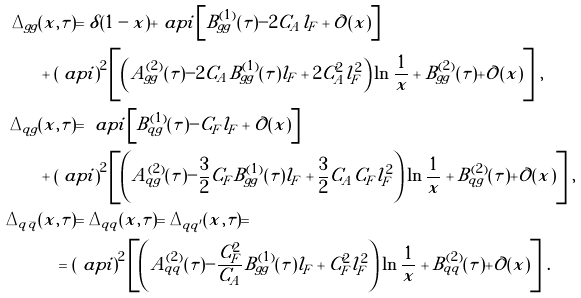<formula> <loc_0><loc_0><loc_500><loc_500>\Delta _ { g g } & ( x , \tau ) = \delta ( 1 - x ) + \ a p i \left [ B ^ { ( 1 ) } _ { g g } ( \tau ) - 2 C _ { A } l _ { F } + \mathcal { O } ( x ) \right ] \\ & + \left ( \ a p i \right ) ^ { 2 } \left [ \left ( A ^ { ( 2 ) } _ { g g } ( \tau ) - 2 C _ { A } B ^ { ( 1 ) } _ { g g } ( \tau ) l _ { F } + 2 C _ { A } ^ { 2 } l _ { F } ^ { 2 } \right ) \ln \frac { 1 } { x } + B ^ { ( 2 ) } _ { g g } ( \tau ) + \mathcal { O } ( x ) \right ] \, , \\ \Delta _ { q g } & ( x , \tau ) = \ a p i \left [ B ^ { ( 1 ) } _ { q g } ( \tau ) - C _ { F } l _ { F } + \mathcal { O } ( x ) \right ] \\ & + \left ( \ a p i \right ) ^ { 2 } \left [ \left ( A ^ { ( 2 ) } _ { q g } ( \tau ) - \frac { 3 } { 2 } C _ { F } B ^ { ( 1 ) } _ { g g } ( \tau ) l _ { F } + \frac { 3 } { 2 } C _ { A } C _ { F } l _ { F } ^ { 2 } \right ) \ln \frac { 1 } { x } + B ^ { ( 2 ) } _ { q g } ( \tau ) + \mathcal { O } ( x ) \right ] \, , \\ \Delta _ { q \bar { q } } & ( x , \tau ) = \Delta _ { q q } ( x , \tau ) = \Delta _ { q q ^ { \prime } } ( x , \tau ) = \\ & \quad = \left ( \ a p i \right ) ^ { 2 } \left [ \left ( A ^ { ( 2 ) } _ { q q } ( \tau ) - \frac { C _ { F } ^ { 2 } } { C _ { A } } B ^ { ( 1 ) } _ { g g } ( \tau ) l _ { F } + C _ { F } ^ { 2 } l _ { F } ^ { 2 } \right ) \ln \frac { 1 } { x } + B ^ { ( 2 ) } _ { q q } ( \tau ) + \mathcal { O } ( x ) \right ] \, .</formula> 